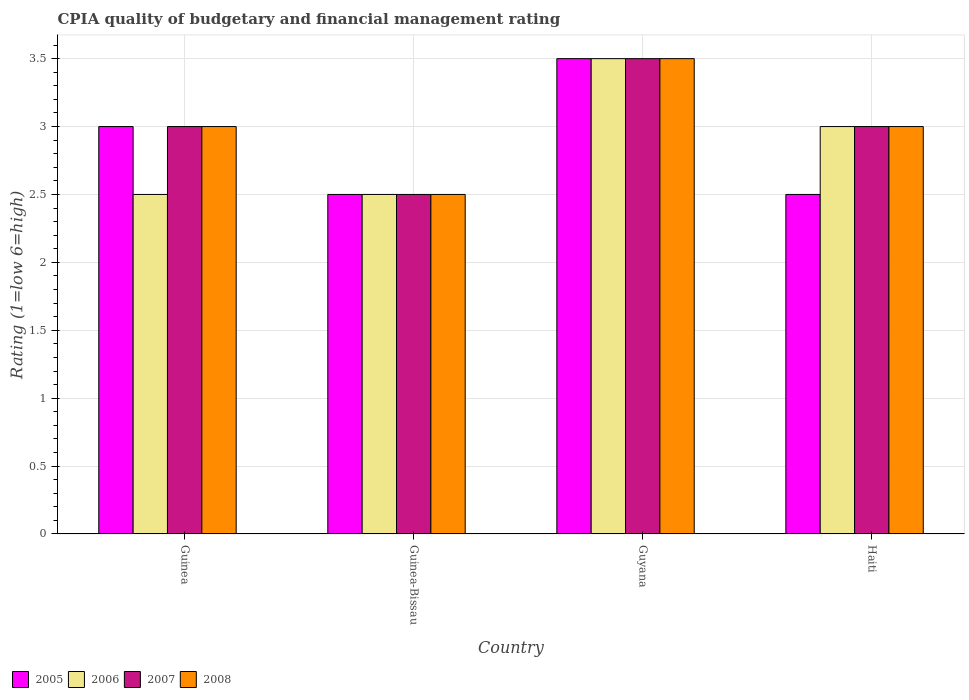How many groups of bars are there?
Your response must be concise. 4. How many bars are there on the 1st tick from the right?
Provide a short and direct response. 4. What is the label of the 2nd group of bars from the left?
Your answer should be compact. Guinea-Bissau. In how many cases, is the number of bars for a given country not equal to the number of legend labels?
Keep it short and to the point. 0. What is the CPIA rating in 2008 in Haiti?
Offer a terse response. 3. Across all countries, what is the maximum CPIA rating in 2008?
Provide a succinct answer. 3.5. Across all countries, what is the minimum CPIA rating in 2007?
Offer a very short reply. 2.5. In which country was the CPIA rating in 2006 maximum?
Offer a terse response. Guyana. In which country was the CPIA rating in 2008 minimum?
Your answer should be very brief. Guinea-Bissau. What is the difference between the CPIA rating in 2006 in Guinea and that in Guyana?
Offer a very short reply. -1. What is the difference between the CPIA rating of/in 2008 and CPIA rating of/in 2007 in Guyana?
Your answer should be compact. 0. What is the ratio of the CPIA rating in 2005 in Guinea to that in Guyana?
Your answer should be compact. 0.86. In how many countries, is the CPIA rating in 2008 greater than the average CPIA rating in 2008 taken over all countries?
Your response must be concise. 1. What does the 3rd bar from the right in Guinea-Bissau represents?
Your answer should be compact. 2006. Is it the case that in every country, the sum of the CPIA rating in 2007 and CPIA rating in 2006 is greater than the CPIA rating in 2008?
Give a very brief answer. Yes. Are all the bars in the graph horizontal?
Your answer should be compact. No. How many countries are there in the graph?
Give a very brief answer. 4. What is the difference between two consecutive major ticks on the Y-axis?
Make the answer very short. 0.5. Are the values on the major ticks of Y-axis written in scientific E-notation?
Provide a short and direct response. No. Does the graph contain grids?
Provide a succinct answer. Yes. Where does the legend appear in the graph?
Provide a succinct answer. Bottom left. How are the legend labels stacked?
Provide a short and direct response. Horizontal. What is the title of the graph?
Your answer should be very brief. CPIA quality of budgetary and financial management rating. Does "2002" appear as one of the legend labels in the graph?
Offer a very short reply. No. What is the label or title of the Y-axis?
Your answer should be compact. Rating (1=low 6=high). What is the Rating (1=low 6=high) of 2005 in Guinea?
Your answer should be very brief. 3. What is the Rating (1=low 6=high) in 2006 in Guinea?
Offer a very short reply. 2.5. What is the Rating (1=low 6=high) in 2008 in Guinea?
Provide a succinct answer. 3. What is the Rating (1=low 6=high) of 2005 in Guinea-Bissau?
Give a very brief answer. 2.5. What is the Rating (1=low 6=high) of 2008 in Guinea-Bissau?
Keep it short and to the point. 2.5. What is the Rating (1=low 6=high) of 2005 in Guyana?
Provide a succinct answer. 3.5. What is the Rating (1=low 6=high) of 2007 in Guyana?
Offer a very short reply. 3.5. What is the Rating (1=low 6=high) of 2008 in Guyana?
Your response must be concise. 3.5. What is the Rating (1=low 6=high) of 2005 in Haiti?
Provide a short and direct response. 2.5. What is the Rating (1=low 6=high) in 2006 in Haiti?
Your answer should be very brief. 3. What is the Rating (1=low 6=high) of 2007 in Haiti?
Offer a terse response. 3. What is the Rating (1=low 6=high) in 2008 in Haiti?
Your answer should be very brief. 3. Across all countries, what is the maximum Rating (1=low 6=high) in 2005?
Provide a short and direct response. 3.5. Across all countries, what is the maximum Rating (1=low 6=high) in 2008?
Make the answer very short. 3.5. Across all countries, what is the minimum Rating (1=low 6=high) of 2006?
Provide a succinct answer. 2.5. Across all countries, what is the minimum Rating (1=low 6=high) in 2007?
Keep it short and to the point. 2.5. Across all countries, what is the minimum Rating (1=low 6=high) of 2008?
Provide a short and direct response. 2.5. What is the total Rating (1=low 6=high) of 2006 in the graph?
Provide a succinct answer. 11.5. What is the total Rating (1=low 6=high) of 2008 in the graph?
Ensure brevity in your answer.  12. What is the difference between the Rating (1=low 6=high) in 2005 in Guinea and that in Guinea-Bissau?
Offer a very short reply. 0.5. What is the difference between the Rating (1=low 6=high) in 2006 in Guinea and that in Guyana?
Your response must be concise. -1. What is the difference between the Rating (1=low 6=high) in 2008 in Guinea and that in Haiti?
Your answer should be very brief. 0. What is the difference between the Rating (1=low 6=high) in 2005 in Guinea-Bissau and that in Guyana?
Offer a terse response. -1. What is the difference between the Rating (1=low 6=high) in 2006 in Guinea-Bissau and that in Guyana?
Offer a terse response. -1. What is the difference between the Rating (1=low 6=high) in 2005 in Guinea-Bissau and that in Haiti?
Give a very brief answer. 0. What is the difference between the Rating (1=low 6=high) in 2007 in Guinea-Bissau and that in Haiti?
Provide a short and direct response. -0.5. What is the difference between the Rating (1=low 6=high) of 2006 in Guyana and that in Haiti?
Your answer should be compact. 0.5. What is the difference between the Rating (1=low 6=high) of 2005 in Guinea and the Rating (1=low 6=high) of 2008 in Guinea-Bissau?
Provide a succinct answer. 0.5. What is the difference between the Rating (1=low 6=high) of 2006 in Guinea and the Rating (1=low 6=high) of 2007 in Guinea-Bissau?
Your response must be concise. 0. What is the difference between the Rating (1=low 6=high) of 2005 in Guinea and the Rating (1=low 6=high) of 2006 in Guyana?
Give a very brief answer. -0.5. What is the difference between the Rating (1=low 6=high) of 2005 in Guinea and the Rating (1=low 6=high) of 2007 in Guyana?
Provide a succinct answer. -0.5. What is the difference between the Rating (1=low 6=high) of 2006 in Guinea and the Rating (1=low 6=high) of 2008 in Guyana?
Provide a short and direct response. -1. What is the difference between the Rating (1=low 6=high) of 2005 in Guinea and the Rating (1=low 6=high) of 2006 in Haiti?
Your answer should be very brief. 0. What is the difference between the Rating (1=low 6=high) in 2006 in Guinea and the Rating (1=low 6=high) in 2008 in Haiti?
Offer a terse response. -0.5. What is the difference between the Rating (1=low 6=high) in 2005 in Guinea-Bissau and the Rating (1=low 6=high) in 2006 in Guyana?
Keep it short and to the point. -1. What is the difference between the Rating (1=low 6=high) in 2006 in Guinea-Bissau and the Rating (1=low 6=high) in 2008 in Guyana?
Give a very brief answer. -1. What is the difference between the Rating (1=low 6=high) in 2006 in Guinea-Bissau and the Rating (1=low 6=high) in 2008 in Haiti?
Offer a very short reply. -0.5. What is the difference between the Rating (1=low 6=high) in 2006 in Guyana and the Rating (1=low 6=high) in 2007 in Haiti?
Your response must be concise. 0.5. What is the difference between the Rating (1=low 6=high) of 2006 in Guyana and the Rating (1=low 6=high) of 2008 in Haiti?
Your response must be concise. 0.5. What is the difference between the Rating (1=low 6=high) in 2007 in Guyana and the Rating (1=low 6=high) in 2008 in Haiti?
Your answer should be very brief. 0.5. What is the average Rating (1=low 6=high) in 2005 per country?
Give a very brief answer. 2.88. What is the average Rating (1=low 6=high) of 2006 per country?
Offer a very short reply. 2.88. What is the average Rating (1=low 6=high) of 2008 per country?
Keep it short and to the point. 3. What is the difference between the Rating (1=low 6=high) in 2005 and Rating (1=low 6=high) in 2006 in Guinea?
Offer a terse response. 0.5. What is the difference between the Rating (1=low 6=high) in 2005 and Rating (1=low 6=high) in 2007 in Guinea?
Your response must be concise. 0. What is the difference between the Rating (1=low 6=high) in 2006 and Rating (1=low 6=high) in 2007 in Guinea?
Offer a very short reply. -0.5. What is the difference between the Rating (1=low 6=high) of 2006 and Rating (1=low 6=high) of 2008 in Guinea?
Ensure brevity in your answer.  -0.5. What is the difference between the Rating (1=low 6=high) in 2007 and Rating (1=low 6=high) in 2008 in Guinea?
Your response must be concise. 0. What is the difference between the Rating (1=low 6=high) in 2005 and Rating (1=low 6=high) in 2006 in Guinea-Bissau?
Your response must be concise. 0. What is the difference between the Rating (1=low 6=high) of 2005 and Rating (1=low 6=high) of 2007 in Guinea-Bissau?
Keep it short and to the point. 0. What is the difference between the Rating (1=low 6=high) in 2005 and Rating (1=low 6=high) in 2008 in Guinea-Bissau?
Ensure brevity in your answer.  0. What is the difference between the Rating (1=low 6=high) of 2006 and Rating (1=low 6=high) of 2008 in Guyana?
Your answer should be compact. 0. What is the ratio of the Rating (1=low 6=high) of 2005 in Guinea to that in Guinea-Bissau?
Offer a terse response. 1.2. What is the ratio of the Rating (1=low 6=high) of 2008 in Guinea to that in Guinea-Bissau?
Your response must be concise. 1.2. What is the ratio of the Rating (1=low 6=high) of 2005 in Guinea to that in Guyana?
Ensure brevity in your answer.  0.86. What is the ratio of the Rating (1=low 6=high) in 2008 in Guinea to that in Guyana?
Offer a very short reply. 0.86. What is the ratio of the Rating (1=low 6=high) in 2005 in Guinea to that in Haiti?
Your answer should be very brief. 1.2. What is the ratio of the Rating (1=low 6=high) in 2006 in Guinea to that in Haiti?
Keep it short and to the point. 0.83. What is the ratio of the Rating (1=low 6=high) in 2007 in Guinea to that in Haiti?
Offer a very short reply. 1. What is the ratio of the Rating (1=low 6=high) of 2008 in Guinea to that in Haiti?
Offer a very short reply. 1. What is the ratio of the Rating (1=low 6=high) of 2005 in Guinea-Bissau to that in Guyana?
Your response must be concise. 0.71. What is the ratio of the Rating (1=low 6=high) of 2006 in Guinea-Bissau to that in Guyana?
Provide a short and direct response. 0.71. What is the ratio of the Rating (1=low 6=high) in 2007 in Guinea-Bissau to that in Guyana?
Your answer should be compact. 0.71. What is the ratio of the Rating (1=low 6=high) of 2008 in Guinea-Bissau to that in Guyana?
Offer a very short reply. 0.71. What is the ratio of the Rating (1=low 6=high) in 2005 in Guinea-Bissau to that in Haiti?
Your answer should be compact. 1. What is the ratio of the Rating (1=low 6=high) in 2006 in Guinea-Bissau to that in Haiti?
Provide a short and direct response. 0.83. What is the ratio of the Rating (1=low 6=high) of 2005 in Guyana to that in Haiti?
Keep it short and to the point. 1.4. What is the difference between the highest and the second highest Rating (1=low 6=high) of 2007?
Offer a very short reply. 0.5. What is the difference between the highest and the second highest Rating (1=low 6=high) in 2008?
Provide a succinct answer. 0.5. What is the difference between the highest and the lowest Rating (1=low 6=high) in 2005?
Your answer should be very brief. 1. What is the difference between the highest and the lowest Rating (1=low 6=high) in 2007?
Make the answer very short. 1. What is the difference between the highest and the lowest Rating (1=low 6=high) in 2008?
Provide a succinct answer. 1. 